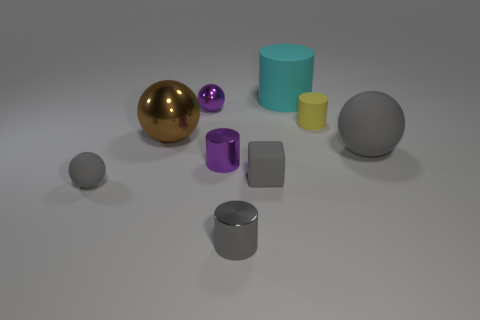Subtract 1 cylinders. How many cylinders are left? 3 Add 1 tiny cyan cylinders. How many objects exist? 10 Subtract all cylinders. How many objects are left? 5 Add 6 large cyan rubber things. How many large cyan rubber things are left? 7 Add 6 blue rubber cylinders. How many blue rubber cylinders exist? 6 Subtract 1 brown balls. How many objects are left? 8 Subtract all large gray things. Subtract all big gray objects. How many objects are left? 7 